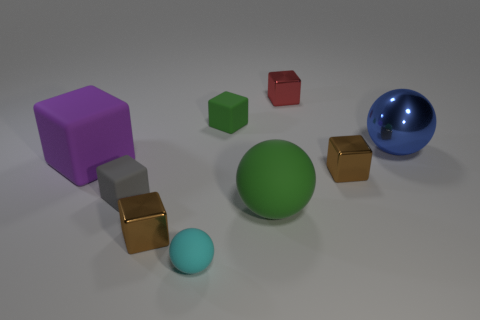Subtract all cyan balls. How many balls are left? 2 Add 1 big gray shiny cylinders. How many objects exist? 10 Subtract all purple cubes. How many cubes are left? 5 Subtract 1 blocks. How many blocks are left? 5 Add 8 green blocks. How many green blocks are left? 9 Add 8 purple matte blocks. How many purple matte blocks exist? 9 Subtract 0 brown cylinders. How many objects are left? 9 Subtract all cubes. How many objects are left? 3 Subtract all gray blocks. Subtract all brown cylinders. How many blocks are left? 5 Subtract all green cylinders. How many purple blocks are left? 1 